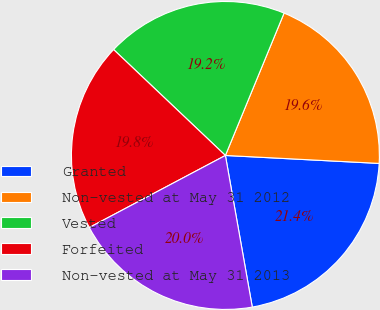Convert chart to OTSL. <chart><loc_0><loc_0><loc_500><loc_500><pie_chart><fcel>Granted<fcel>Non-vested at May 31 2012<fcel>Vested<fcel>Forfeited<fcel>Non-vested at May 31 2013<nl><fcel>21.38%<fcel>19.6%<fcel>19.15%<fcel>19.82%<fcel>20.04%<nl></chart> 